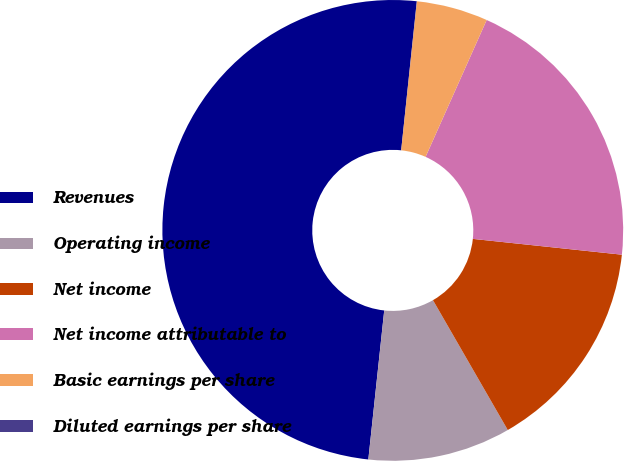Convert chart. <chart><loc_0><loc_0><loc_500><loc_500><pie_chart><fcel>Revenues<fcel>Operating income<fcel>Net income<fcel>Net income attributable to<fcel>Basic earnings per share<fcel>Diluted earnings per share<nl><fcel>49.97%<fcel>10.01%<fcel>15.0%<fcel>20.0%<fcel>5.01%<fcel>0.01%<nl></chart> 